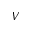Convert formula to latex. <formula><loc_0><loc_0><loc_500><loc_500>V</formula> 